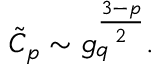Convert formula to latex. <formula><loc_0><loc_0><loc_500><loc_500>\tilde { C } _ { p } \sim g _ { q } ^ { \frac { 3 - p } { 2 } } .</formula> 